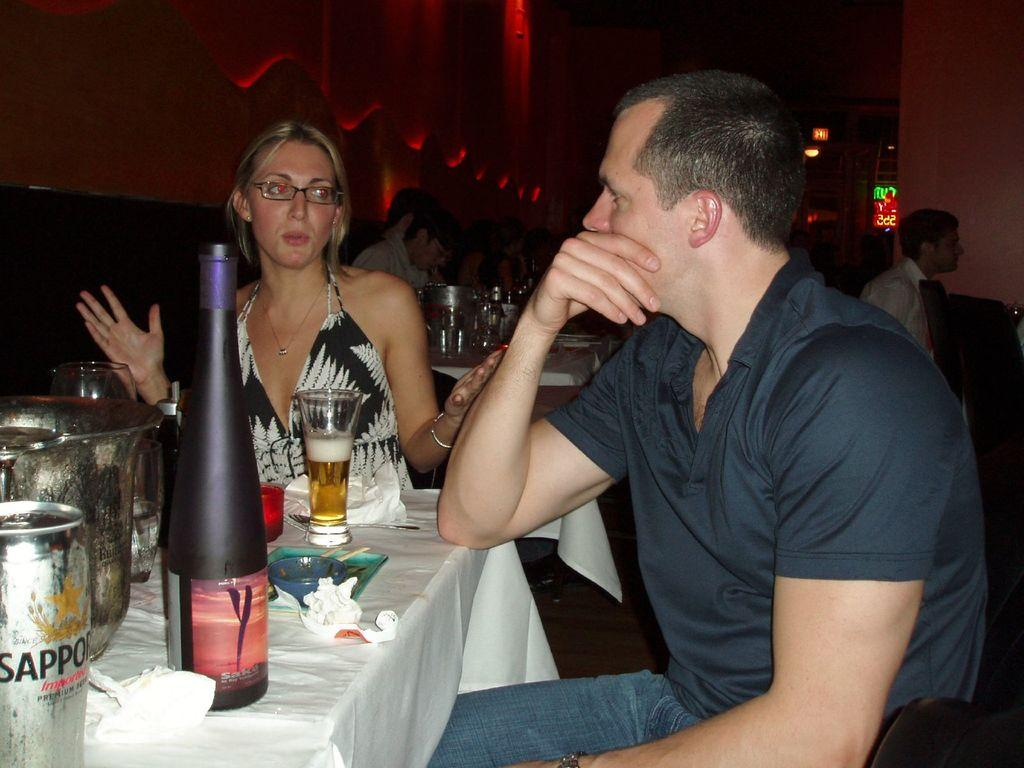<image>
Describe the image concisely. A man and woman talk at a table which has many alcoholic beverages on it including a can of Sapporo beer. 